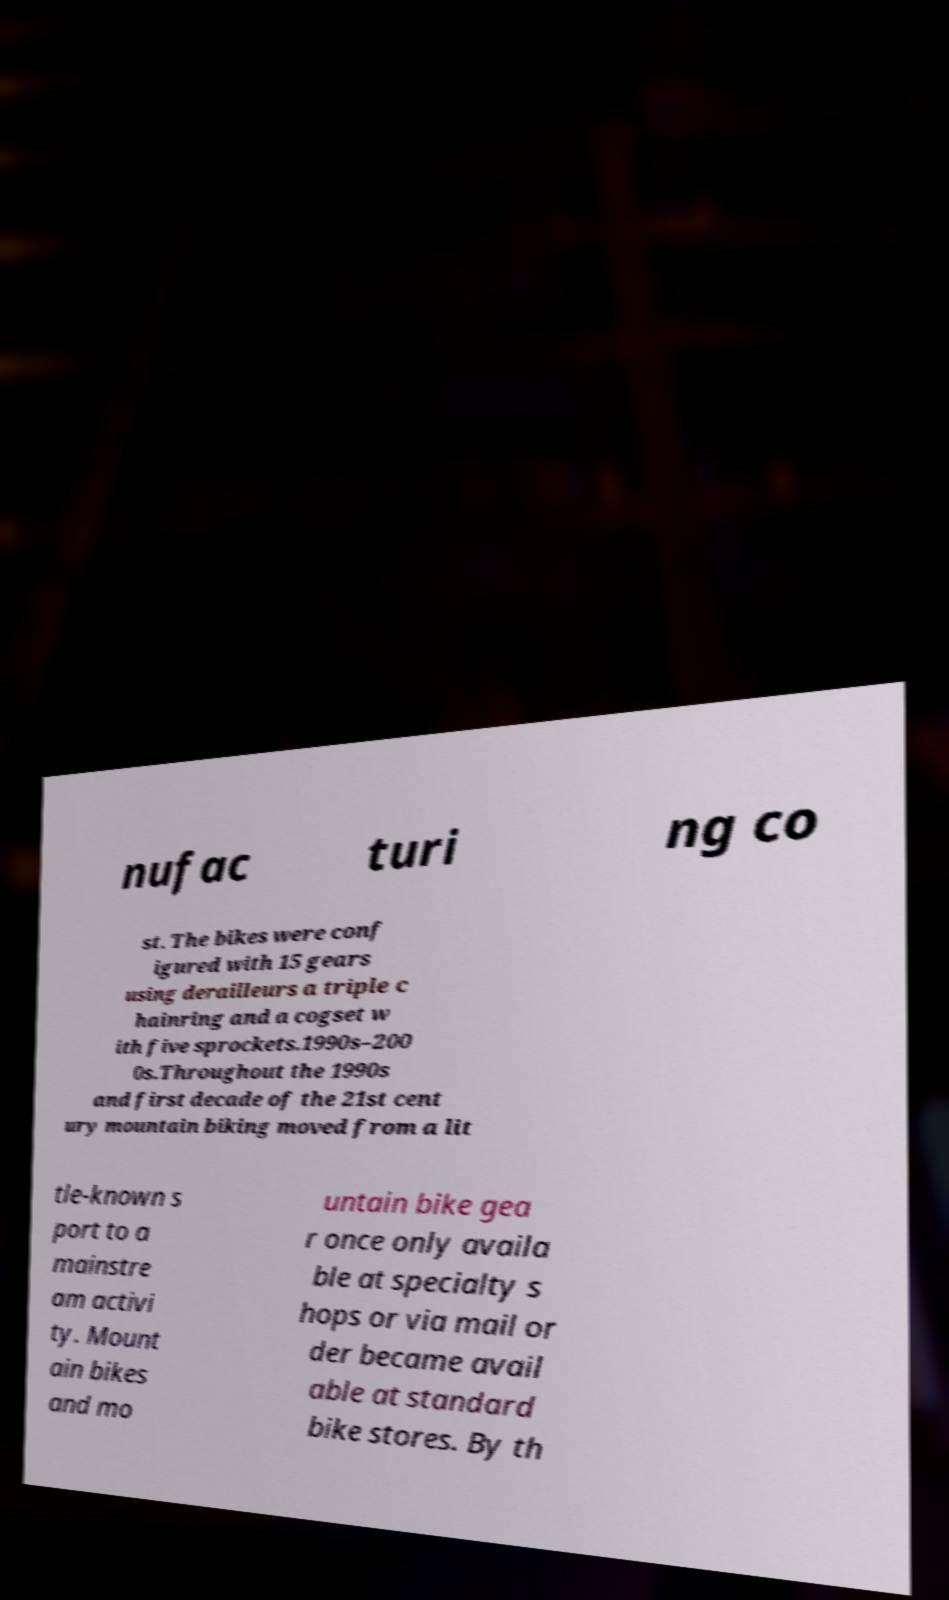For documentation purposes, I need the text within this image transcribed. Could you provide that? nufac turi ng co st. The bikes were conf igured with 15 gears using derailleurs a triple c hainring and a cogset w ith five sprockets.1990s–200 0s.Throughout the 1990s and first decade of the 21st cent ury mountain biking moved from a lit tle-known s port to a mainstre am activi ty. Mount ain bikes and mo untain bike gea r once only availa ble at specialty s hops or via mail or der became avail able at standard bike stores. By th 